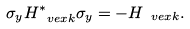<formula> <loc_0><loc_0><loc_500><loc_500>\sigma _ { y } H _ { \ v e x k } ^ { * } \sigma _ { y } = - H _ { \ v e x k } .</formula> 